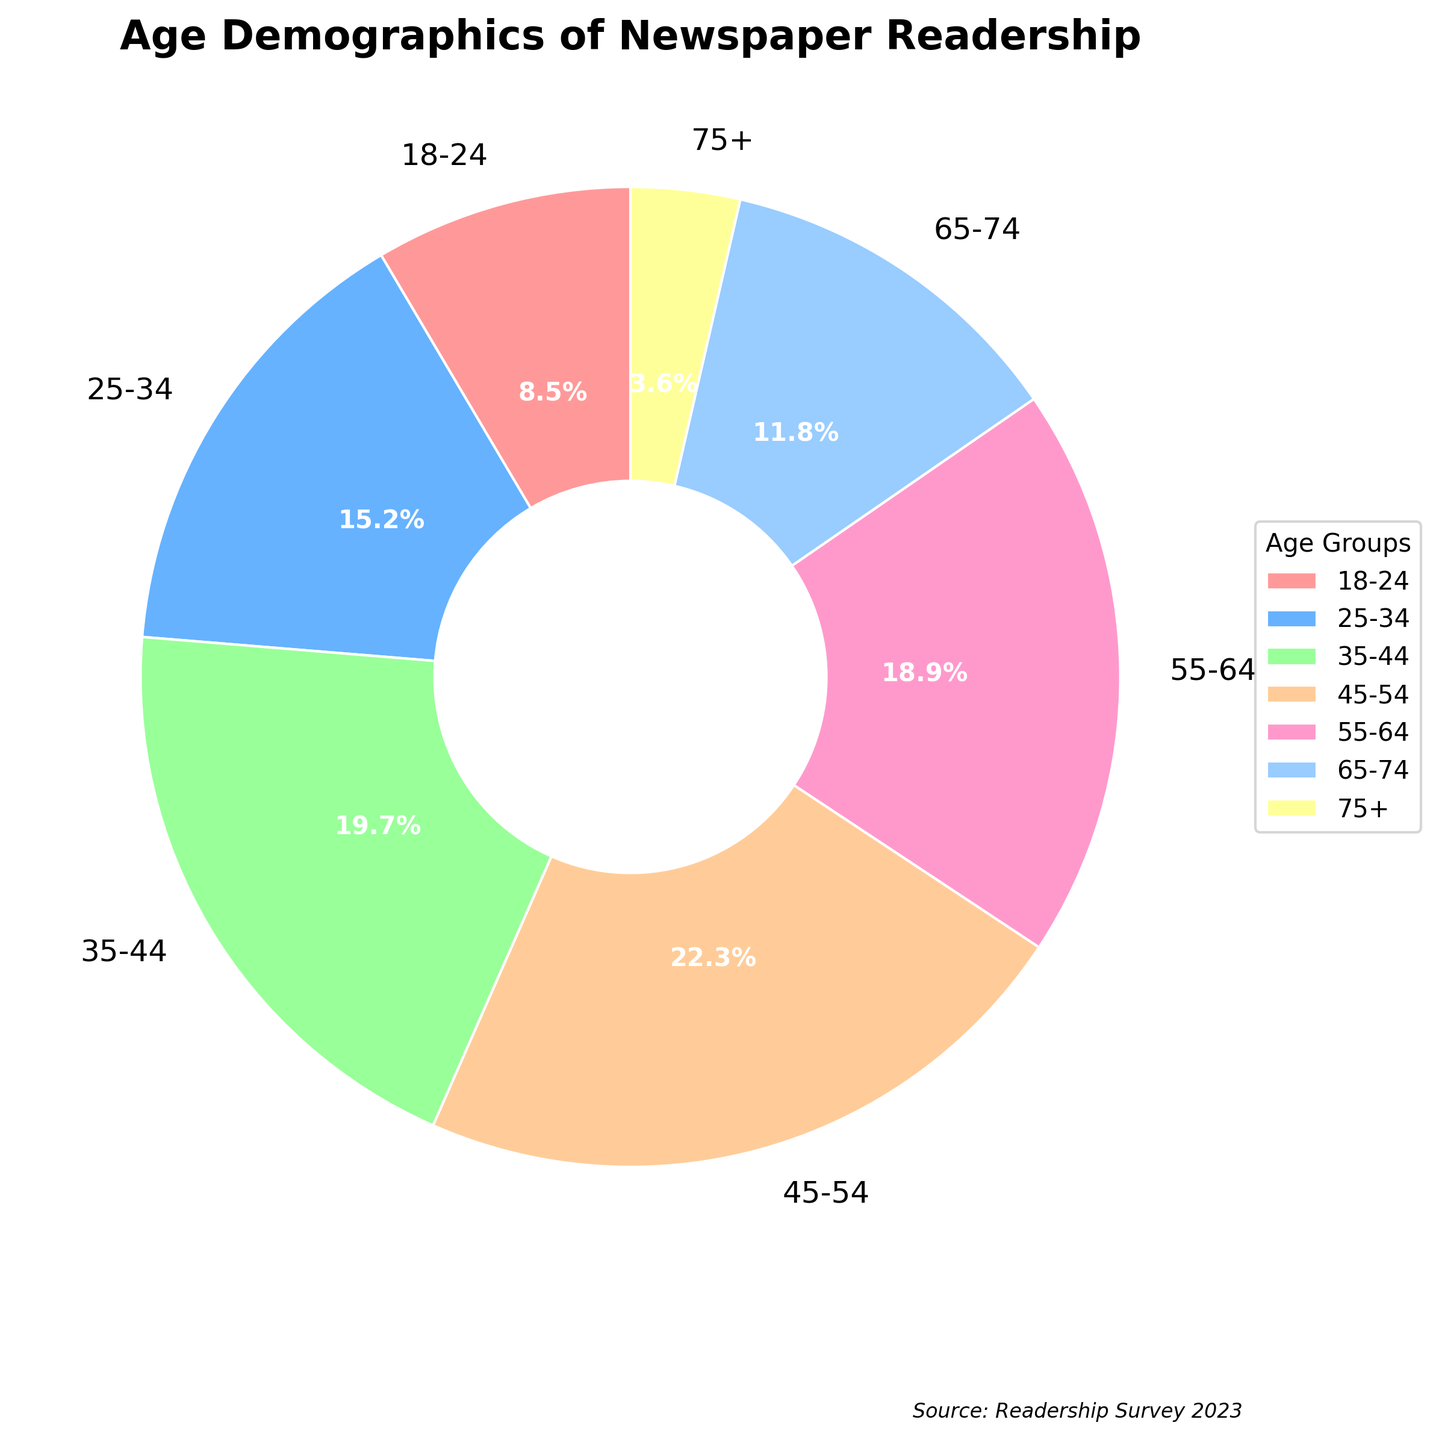Which age group has the highest percentage of readership? By looking at the chart, the slice corresponding to the 45-54 age group is the largest. Therefore, the 45-54 age group has the highest percentage of readership at 22.3%.
Answer: 45-54 What is the combined percentage of readership for the age groups 18-24 and 65-74? First, find the percentages for the 18-24 and 65-74 age groups, which are 8.5% and 11.8% respectively. Then, add them together: 8.5% + 11.8% = 20.3%.
Answer: 20.3% How much larger is the readership percentage of the 35-44 age group compared to the 25-34 age group? The percentage for the 35-44 age group is 19.7% and for the 25-34 age group is 15.2%. The difference is 19.7% - 15.2% = 4.5%.
Answer: 4.5% Which age group has the smallest slice in the pie chart? The smallest slice in the pie chart corresponds to the 75+ age group, which has a percentage of 3.6%.
Answer: 75+ What percentage of the readership is aged 55 and above? Add the percentages of the 55-64, 65-74, and 75+ age groups: 18.9% + 11.8% + 3.6% = 34.3%.
Answer: 34.3% Which two age groups make up approximately 35% of the readership when combined? Adding the percentages of the 18-24 and 25-34 age groups gives 8.5% + 15.2% = 23.7%, which is too low. Adding the percentages of the 25-34 and 35-44 age groups gives 15.2% + 19.7% = 34.9%, which is approximately 35%.
Answer: 25-34 and 35-44 What is the difference in readership percentage between the 55-64 age group and the 65-74 age group? The percentage for the 55-64 age group is 18.9% and for the 65-74 age group is 11.8%. The difference is 18.9% - 11.8% = 7.1%.
Answer: 7.1% If we were to combine the two smallest age groups, what percentage of the readership would they make up? The two smallest age groups are 75+ and 18-24, with percentages 3.6% and 8.5%. Adding these gives 3.6% + 8.5% = 12.1%.
Answer: 12.1% What is the average percentage of readership across all age groups? Sum the percentages for all age groups and then divide by the number of age groups: (8.5% + 15.2% + 19.7% + 22.3% + 18.9% + 11.8% + 3.6%) / 7 = 100% / 7 ≈ 14.3%.
Answer: 14.3% 